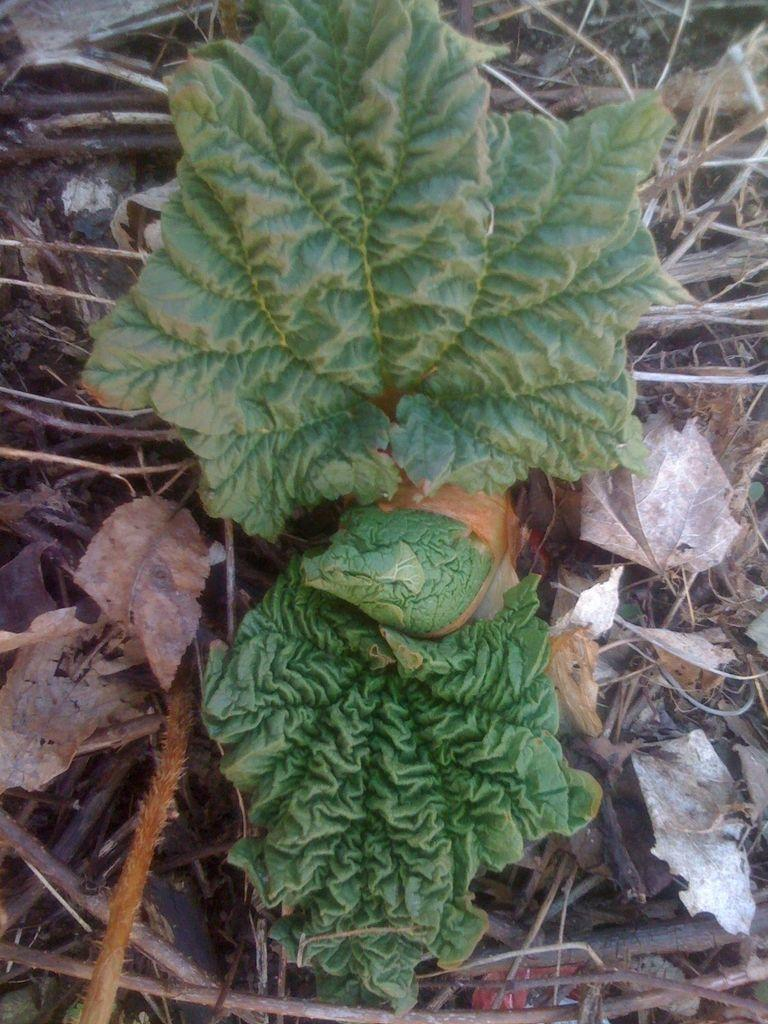What type of plant is visible in the image? There is a plant in the image, but its specific type is not mentioned. What is the condition of the leaves near the plant? The leaves near the plant are dried. What other objects are near the plant? There are sticks near the plant, as well as other unspecified things. What type of band is playing music near the plant in the image? There is no band present in the image; it only features a plant, dried leaves, sticks, and unspecified things. 